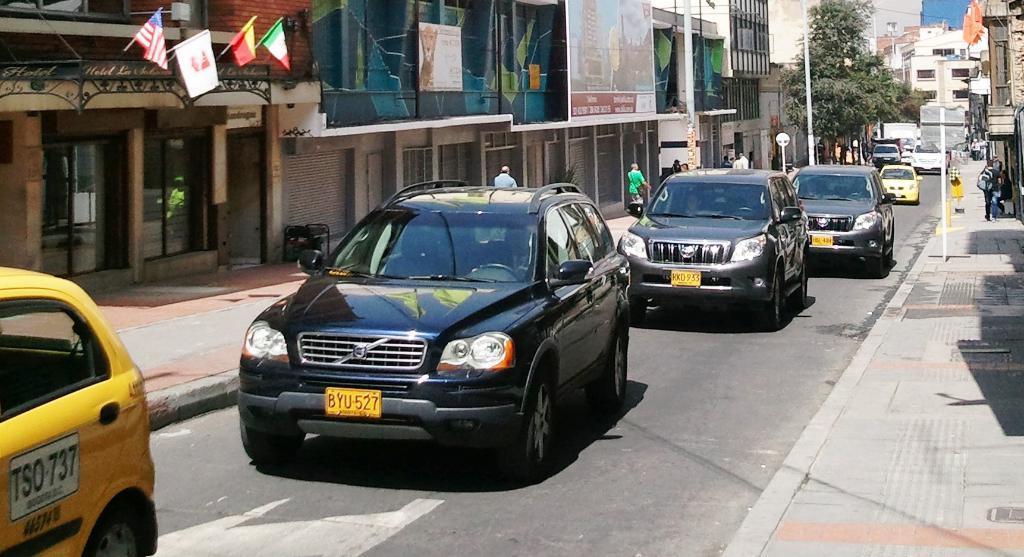How would you summarize this image in a sentence or two? I can see the cars on the road. These are the flags hanging to the poles. This looks like a hoarding. These are the buildings with glass doors. I can see few people walking. This is the tree. I can see the poles beside the road. 